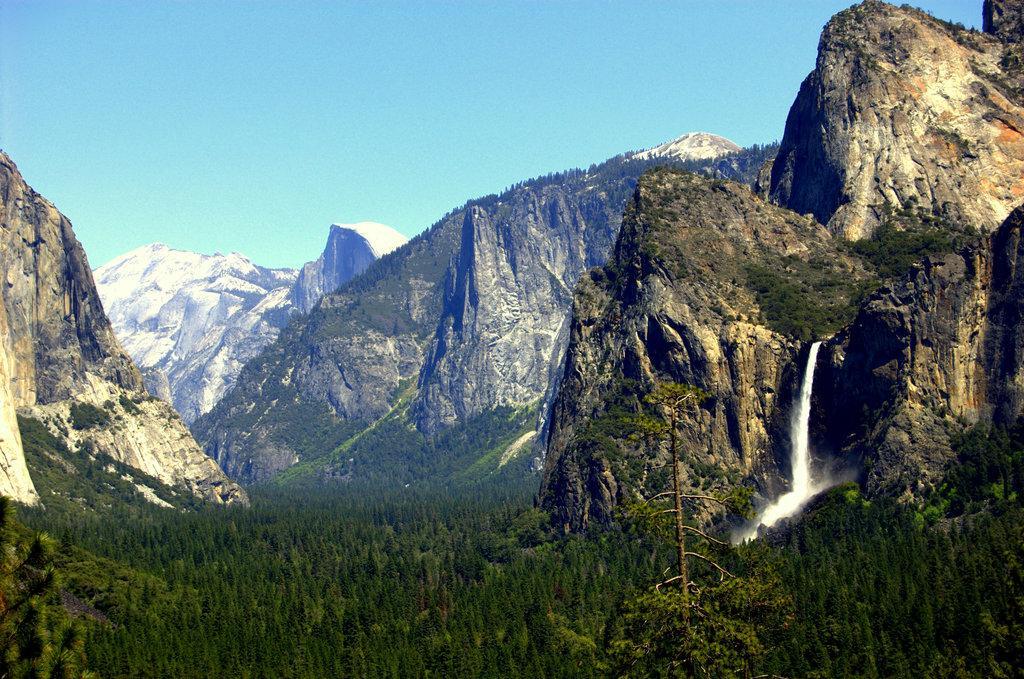How would you summarize this image in a sentence or two? In this picture I can see few hills and water flowing and I can see trees and a blue sky. 